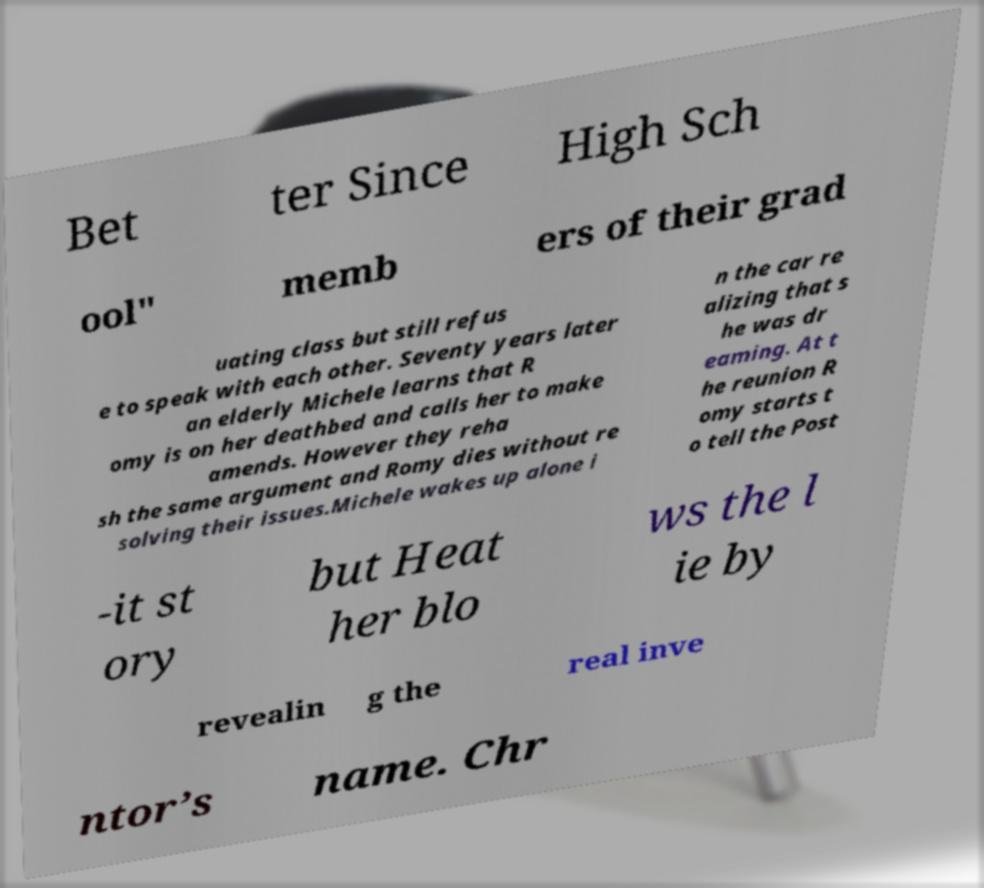I need the written content from this picture converted into text. Can you do that? Bet ter Since High Sch ool" memb ers of their grad uating class but still refus e to speak with each other. Seventy years later an elderly Michele learns that R omy is on her deathbed and calls her to make amends. However they reha sh the same argument and Romy dies without re solving their issues.Michele wakes up alone i n the car re alizing that s he was dr eaming. At t he reunion R omy starts t o tell the Post -it st ory but Heat her blo ws the l ie by revealin g the real inve ntor’s name. Chr 